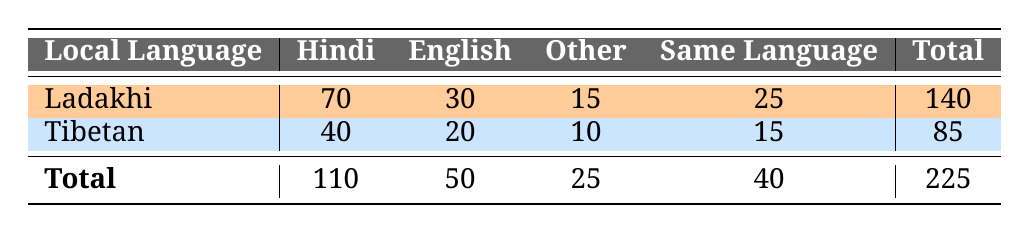What is the frequency of using Ladakhi with Hindi in everyday communication? The table shows that the frequency of using Ladakhi with Hindi is 70.
Answer: 70 What is the total frequency of communication in Tibetan? To find the total frequency for Tibetan, we add the values in the Tibetan row: 40 (Hindi) + 20 (English) + 10 (Other) + 15 (Same Language) = 85.
Answer: 85 Is there a higher preference for Hindi or English when communicating in Ladakhi? To determine this, we compare the values: 70 (Ladakhi with Hindi) is greater than 30 (Ladakhi with English), therefore there is a higher preference for Hindi.
Answer: Yes How many more people communicate in Hindi than in Other languages overall? To find this, first sum the total usage for Hindi (110) and Other languages (25). The difference is 110 - 25 = 85.
Answer: 85 What proportion of Tibeteans communicate in the same language compared to the total number communicating in Tibetan? The number of Tibeteans who communicate in the same language is 15. The total for Tibeteans is 85, so the proportion is 15 / 85 = 0.1765, which is approximately 17.65%.
Answer: 17.65% Which local language is used more frequently overall, Ladakhi or Tibetan? The total frequency for Ladakhi is 140 and for Tibetan is 85. Since 140 is greater than 85, Ladakhi is used more frequently overall.
Answer: Ladakhi What is the combined frequency of all national language interactions with Ladakhi? To find the combined frequency of all national language interactions with Ladakhi, add the values from the Ladakhi row: 70 (Hindi) + 30 (English) + 15 (Other) + 25 (Same Language) = 140.
Answer: 140 What is the frequency of using Tibetan with English? The frequency of using Tibetan with English is specifically listed as 20 in the table.
Answer: 20 How many people use Ladakhi with Other languages compared to all national language communications? The frequency of using Ladakhi with Other languages is 15. To find the total national language communications, we sum: 110 (Hindi) + 50 (English) + 25 (Other) = 185. Hence, 15 is much less than 185.
Answer: Less than 185 